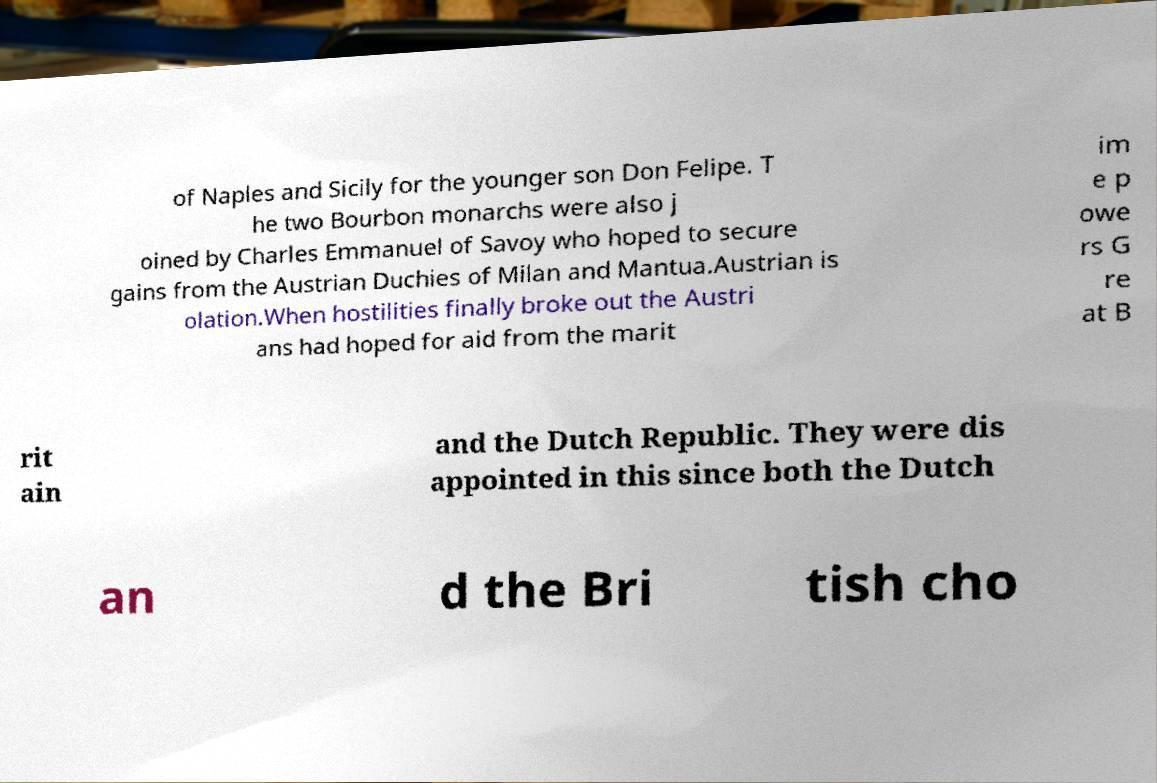Can you accurately transcribe the text from the provided image for me? of Naples and Sicily for the younger son Don Felipe. T he two Bourbon monarchs were also j oined by Charles Emmanuel of Savoy who hoped to secure gains from the Austrian Duchies of Milan and Mantua.Austrian is olation.When hostilities finally broke out the Austri ans had hoped for aid from the marit im e p owe rs G re at B rit ain and the Dutch Republic. They were dis appointed in this since both the Dutch an d the Bri tish cho 